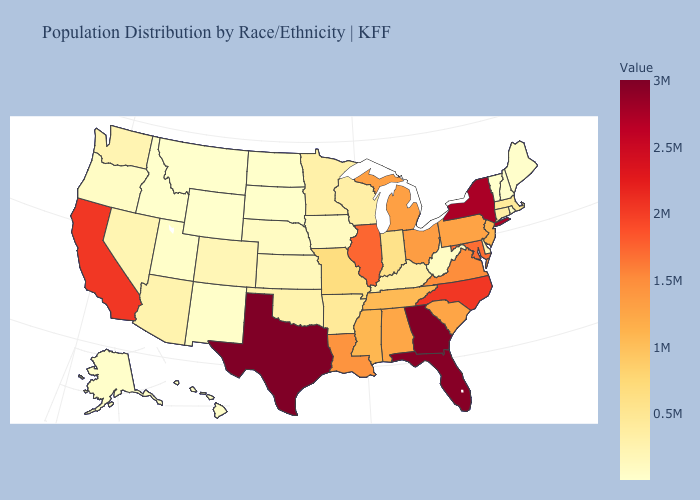Does California have the highest value in the West?
Concise answer only. Yes. Does New York have the highest value in the Northeast?
Concise answer only. Yes. Among the states that border Alabama , does Florida have the lowest value?
Answer briefly. No. Among the states that border California , does Arizona have the lowest value?
Concise answer only. No. Is the legend a continuous bar?
Give a very brief answer. Yes. Does the map have missing data?
Concise answer only. No. 